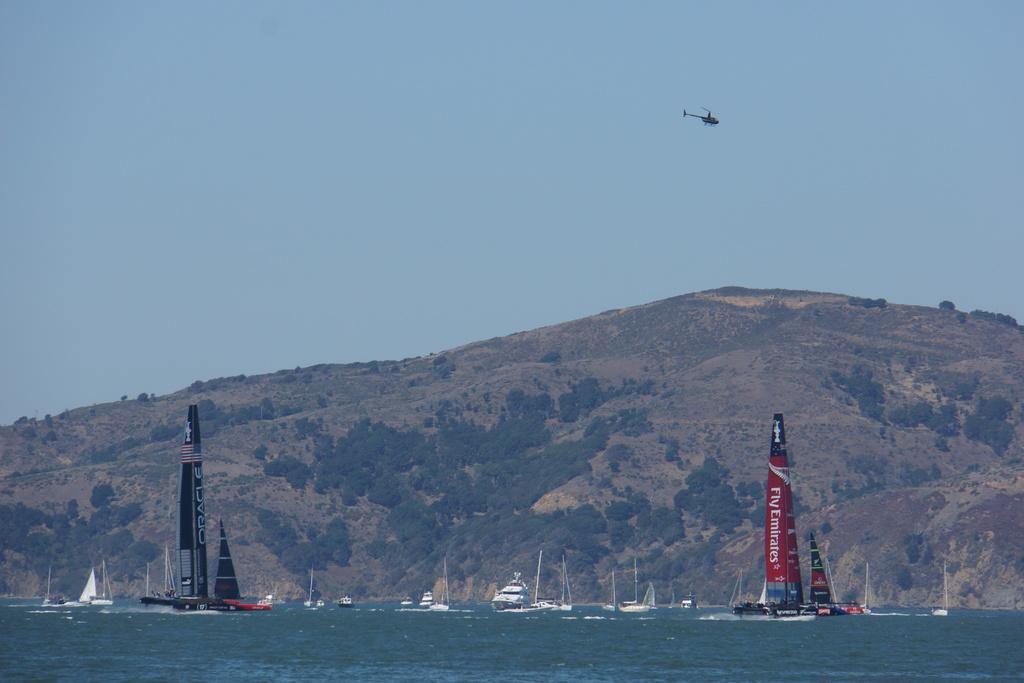What type of location is depicted in the image? There is a beach in the image. What types of watercraft can be seen in the image? There are boats and ships in the image. What geographical feature is visible in the background of the image? There is a mountain in the image. What type of vegetation is present in the image? There are trees in the image. What mode of transportation can be seen in the air in the image? There is a plane in the air in the image. What type of nut is being used to answer questions about the image? There is no nut present in the image, and nuts are not used to answer questions about the image. 